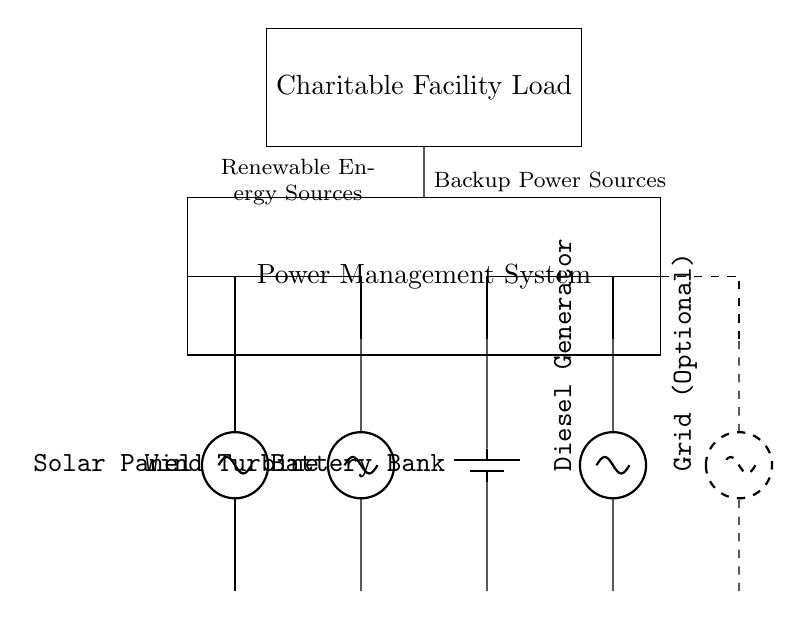What are the renewable energy sources shown in the circuit? The circuit diagram displays a solar panel and a wind turbine as the renewable energy sources connected to the power management system.
Answer: Solar Panel, Wind Turbine What is the purpose of the power management system in this circuit? The power management system coordinates the energy inputs from various sources, ensuring that the load receives power from the most suitable and available source.
Answer: Energy Coordination How many types of power sources are present in the circuit? There are four power sources: two renewable (solar panel, wind turbine) and two backup (battery bank, diesel generator).
Answer: Four What is labeled as the backup power source? The circuit includes a battery bank and a diesel generator, which serve as backup sources to ensure continuous power supply when renewable sources are insufficient.
Answer: Battery Bank, Diesel Generator What additional feature is provided as an optional connection in the circuit? The circuit includes an optional grid connection, which can be utilized for additional power supply when available. This helps in maintaining power availability for the charitable facility.
Answer: Grid Connection How does the load connect to the power management system? The charitable facility load connects directly to the power management system, which manages input from all sources before supplying it to the load. This ensures stability and reliability in power delivery.
Answer: Directly connected 